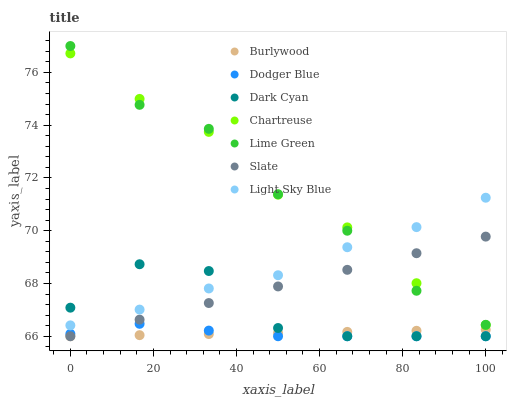Does Dodger Blue have the minimum area under the curve?
Answer yes or no. Yes. Does Chartreuse have the maximum area under the curve?
Answer yes or no. Yes. Does Slate have the minimum area under the curve?
Answer yes or no. No. Does Slate have the maximum area under the curve?
Answer yes or no. No. Is Slate the smoothest?
Answer yes or no. Yes. Is Dark Cyan the roughest?
Answer yes or no. Yes. Is Chartreuse the smoothest?
Answer yes or no. No. Is Chartreuse the roughest?
Answer yes or no. No. Does Burlywood have the lowest value?
Answer yes or no. Yes. Does Chartreuse have the lowest value?
Answer yes or no. No. Does Lime Green have the highest value?
Answer yes or no. Yes. Does Slate have the highest value?
Answer yes or no. No. Is Dodger Blue less than Chartreuse?
Answer yes or no. Yes. Is Light Sky Blue greater than Slate?
Answer yes or no. Yes. Does Dark Cyan intersect Light Sky Blue?
Answer yes or no. Yes. Is Dark Cyan less than Light Sky Blue?
Answer yes or no. No. Is Dark Cyan greater than Light Sky Blue?
Answer yes or no. No. Does Dodger Blue intersect Chartreuse?
Answer yes or no. No. 